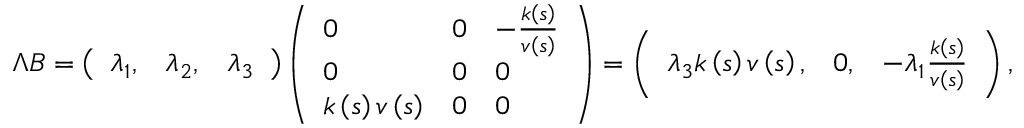Convert formula to latex. <formula><loc_0><loc_0><loc_500><loc_500>\Lambda B = \left ( \begin{array} { l l l } { \lambda _ { 1 } , } & { \lambda _ { 2 } , } & { \lambda _ { 3 } } \end{array} \right ) \left ( \begin{array} { l l l } { 0 } & { 0 } & { - \frac { k \left ( s \right ) } { v \left ( s \right ) } } \\ { 0 } & { 0 } & { 0 } \\ { k \left ( s \right ) v \left ( s \right ) } & { 0 } & { 0 } \end{array} \right ) = \left ( \begin{array} { l l l } { \lambda _ { 3 } k \left ( s \right ) v \left ( s \right ) , } & { 0 , } & { - \lambda _ { 1 } \frac { k \left ( s \right ) } { v \left ( s \right ) } } \end{array} \right ) ,</formula> 